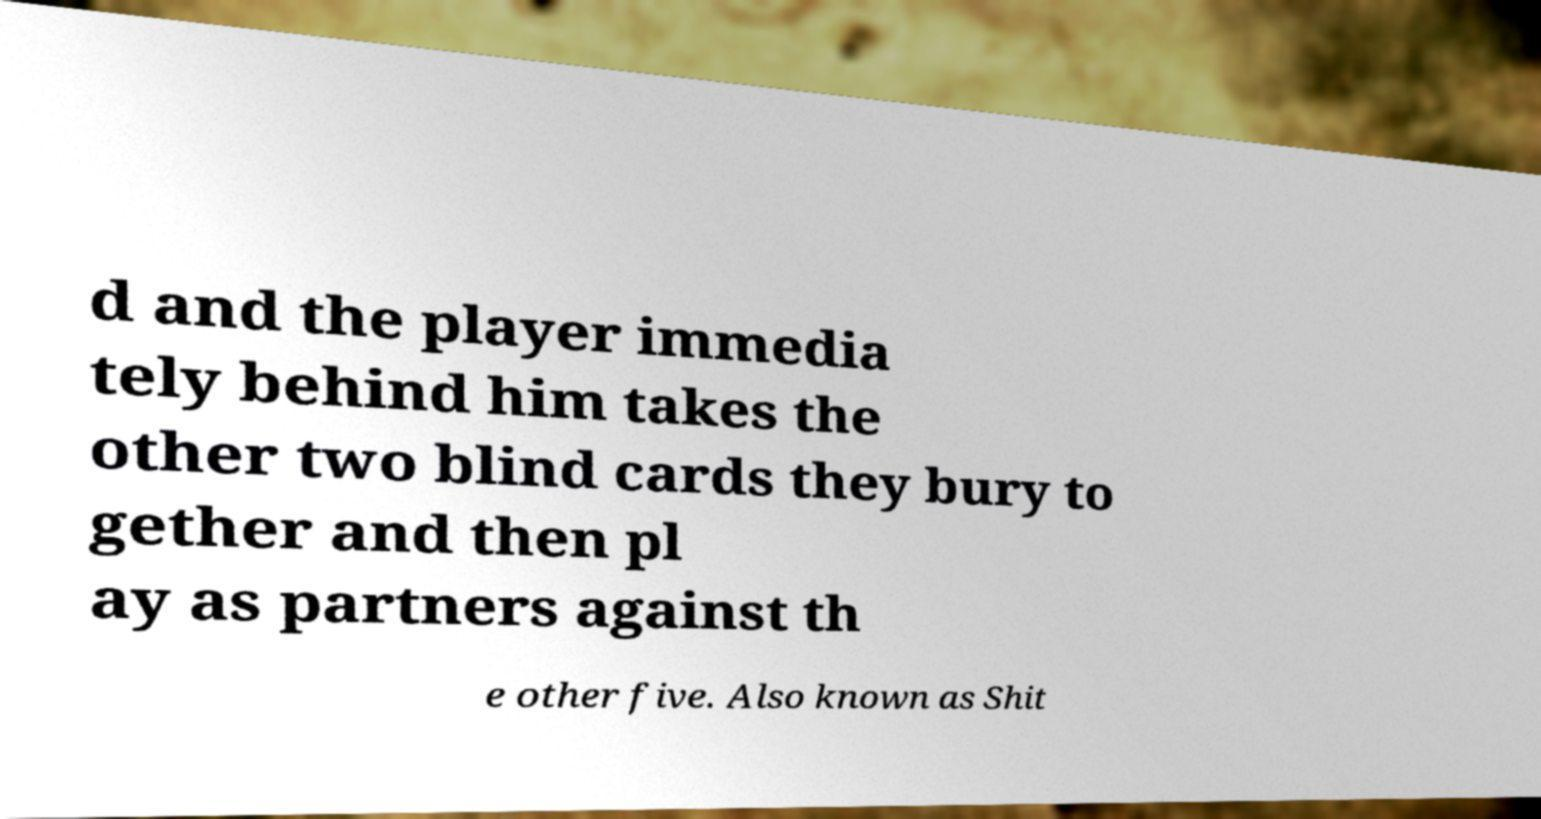Could you assist in decoding the text presented in this image and type it out clearly? d and the player immedia tely behind him takes the other two blind cards they bury to gether and then pl ay as partners against th e other five. Also known as Shit 